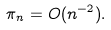<formula> <loc_0><loc_0><loc_500><loc_500>\pi _ { n } = O ( n ^ { - 2 } ) .</formula> 